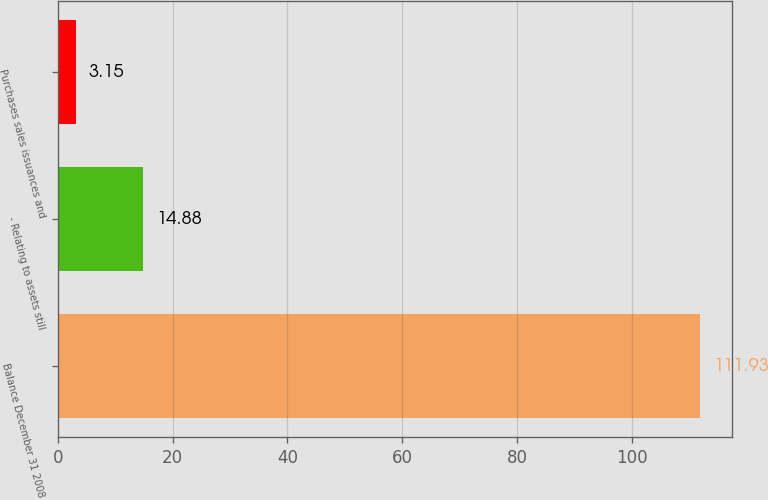<chart> <loc_0><loc_0><loc_500><loc_500><bar_chart><fcel>Balance December 31 2008<fcel>- Relating to assets still<fcel>Purchases sales issuances and<nl><fcel>111.93<fcel>14.88<fcel>3.15<nl></chart> 